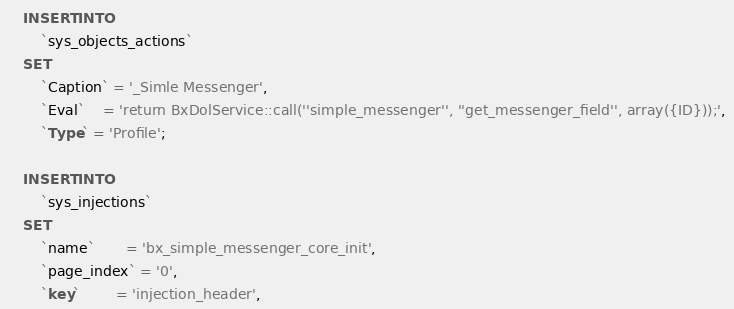<code> <loc_0><loc_0><loc_500><loc_500><_SQL_>
    INSERT INTO 
        `sys_objects_actions` 
    SET
        `Caption` = '_Simle Messenger', 
        `Eval`    = 'return BxDolService::call(''simple_messenger'', ''get_messenger_field'', array({ID}));', 
        `Type` = 'Profile';

    INSERT INTO 
        `sys_injections`
    SET
        `name`       = 'bx_simple_messenger_core_init',
        `page_index` = '0',
        `key`        = 'injection_header',</code> 